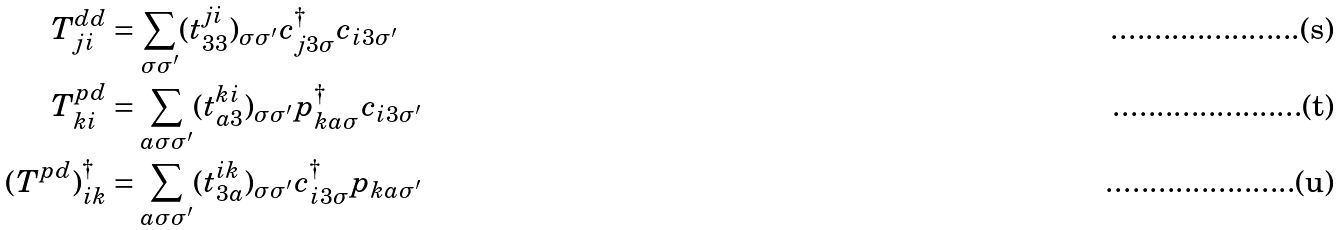<formula> <loc_0><loc_0><loc_500><loc_500>T ^ { d d } _ { j i } & = \sum _ { \sigma \sigma ^ { \prime } } ( t ^ { j i } _ { 3 3 } ) _ { \sigma \sigma ^ { \prime } } c ^ { \dagger } _ { j 3 \sigma } c _ { i 3 \sigma ^ { \prime } } \\ T ^ { p d } _ { k i } & = \sum _ { a \sigma \sigma ^ { \prime } } ( t ^ { k i } _ { a 3 } ) _ { \sigma \sigma ^ { \prime } } p ^ { \dagger } _ { k a \sigma } c _ { i 3 \sigma ^ { \prime } } \\ ( T ^ { p d } ) ^ { \dagger } _ { i k } & = \sum _ { a \sigma \sigma ^ { \prime } } ( t ^ { i k } _ { 3 a } ) _ { \sigma \sigma ^ { \prime } } c ^ { \dagger } _ { i 3 \sigma } p _ { k a \sigma ^ { \prime } }</formula> 